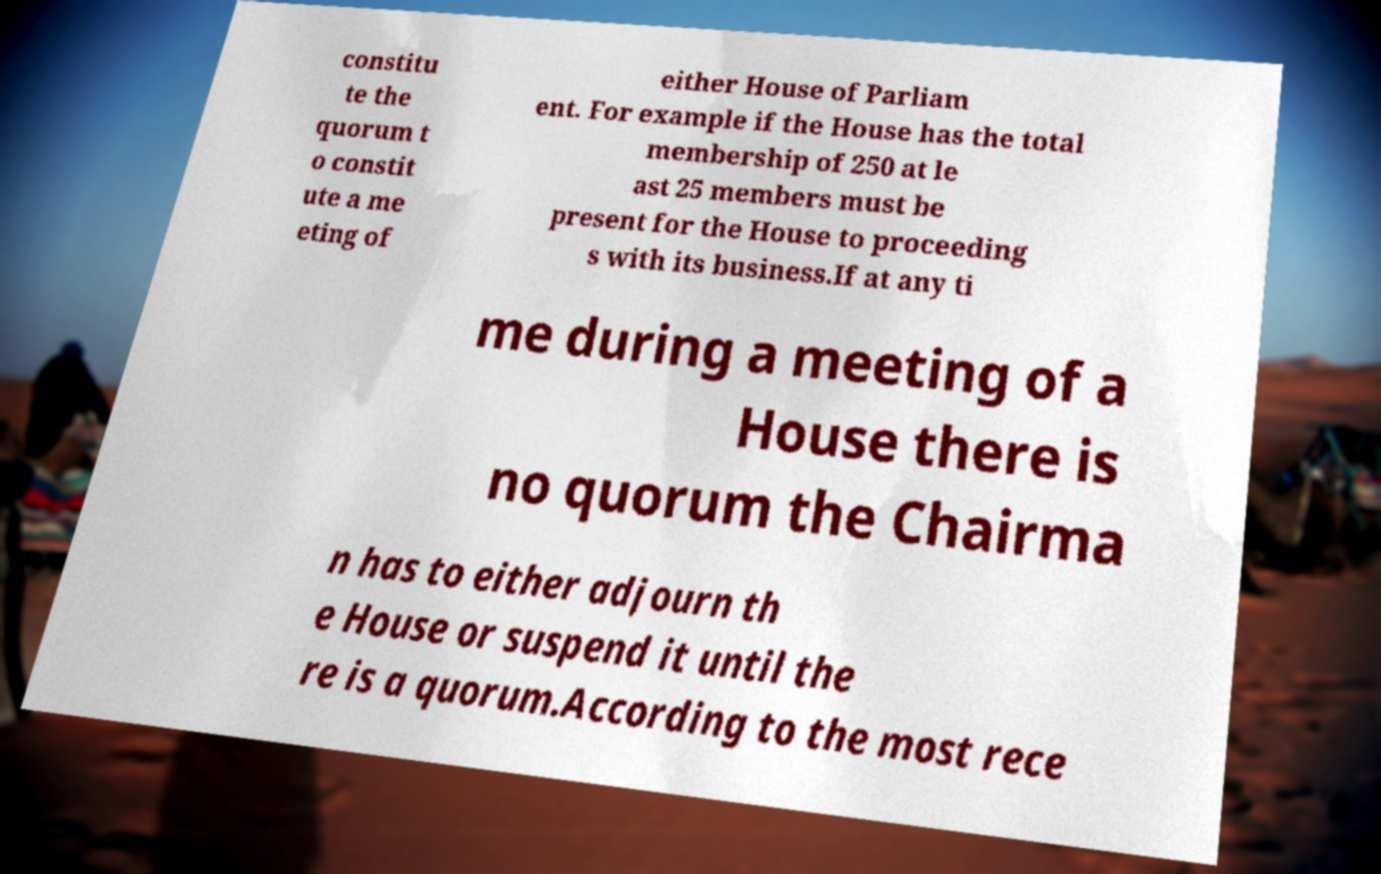I need the written content from this picture converted into text. Can you do that? constitu te the quorum t o constit ute a me eting of either House of Parliam ent. For example if the House has the total membership of 250 at le ast 25 members must be present for the House to proceeding s with its business.If at any ti me during a meeting of a House there is no quorum the Chairma n has to either adjourn th e House or suspend it until the re is a quorum.According to the most rece 